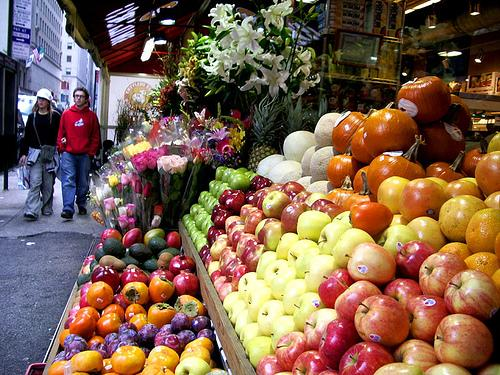Identify the types of fruit that are being displayed and list them. Green apples, cantaloupes, pineapple, orange pumpkins, grapefruits, and red apples are on display. Mention the clothing items and colors of the couple walking down the street. The man is wearing a red sweatshirt and blue jeans, while the woman is wearing a white hat and a black shirt. What detail does the manufacturing sticker on the apple provide? The manufacturing sticker on the apple provides information about the produce. Enumerate the different varieties and colors of flowers in the image. There are white lilies, a large bouquet of white flowers, multi-colored flowers, and pale colored roses. Count the number of avocados and describe their appearance. There are several green avocados on display. Comment on the quality of the image and its depiction of different objects. The image quality is good, providing detailed information on various objects such as fruits, flowers, clothing, and surrounding elements in the scene. What is the colorful item hanging on the building in the background? There are flags hanging on the building in the background. What is the main object of focus for the viewer in the image and explain its significance. The main object of focus is the fruit stand, showcasing a variety of fresh produce for customers to purchase and enjoy. Evaluate the overall sentiment of the image and explain why. The overall sentiment of the image is positive, featuring various fruits and flowers on display, and a happy couple walking down the street. How many flags are hanging on the building in the background? One flag is hanging on the building. List the clothing items worn by the man with the red sweatshirt and the woman with the hat. Red sweatshirt, blue jeans, glasses, white hat, and jacket tied around waist. Describe the interaction between the young man wearing a red hooded sweatshirt and the young woman wearing a hat. They are walking together down the street, engaged in a conversation. What kind of apples are the green apples next to the red apples? Granny Smith apples Describe the store awning in the image. A store front awning located in the top left corner with size Width:178 Height:178. List all the types of flowers present in the image. White lilies and pale colored roses. Based on the various fruits displayed, describe the scene in the image. A busy street scene with a well-stocked fruit stand. What kind of sentiment does the image convey with the couple walking and the objects surrounding them? The image conveys a positive, lively and bustling sentiment. What is the content of the sticker on the apple? Cannot determine, as OCR is not applicable in this situation. What are the pumpkins next to the grapefruits like? The pumpkins are shiny and stacked in a pile. Identify the object attributes for the apples in the image. Color (red, green), size (small, large), type (Granny Smith), and presence of sticker. Identify the main subject in this image based on the objects and people present in it. The fruit stand and the people present in the scene. Describe the quality of the image based on the clarity of the objects. The image quality is good with clear and distinct objects. Which objects are immediately next to the white lilies? A pineapple and a bunch of pale colored roses. Categorize the objects in the image based on their functionality or purpose. People-related items (clothes, glasses, hat), food items (fruits), decorative items (flowers, flags, awning), and location (sidewalk, street, building). Which fruits are displayed at the fruit stand? Green apples, red apples, grapefruits, cantaloupes, avocados, pineapple, and oranges. Identify any anomalies or unusual elements in this image. No anomalies detected, everything seems normal. What color are the avocados and how are they arranged in the image? The avocados are green and arranged in a pile. Describe the sentiment of the image based on the objects and people present in it. Positive and busy, as there are a lot of people, fruits, flowers and colorful items. Is there any text visible in the image that can be read? No text can be read in the image. 